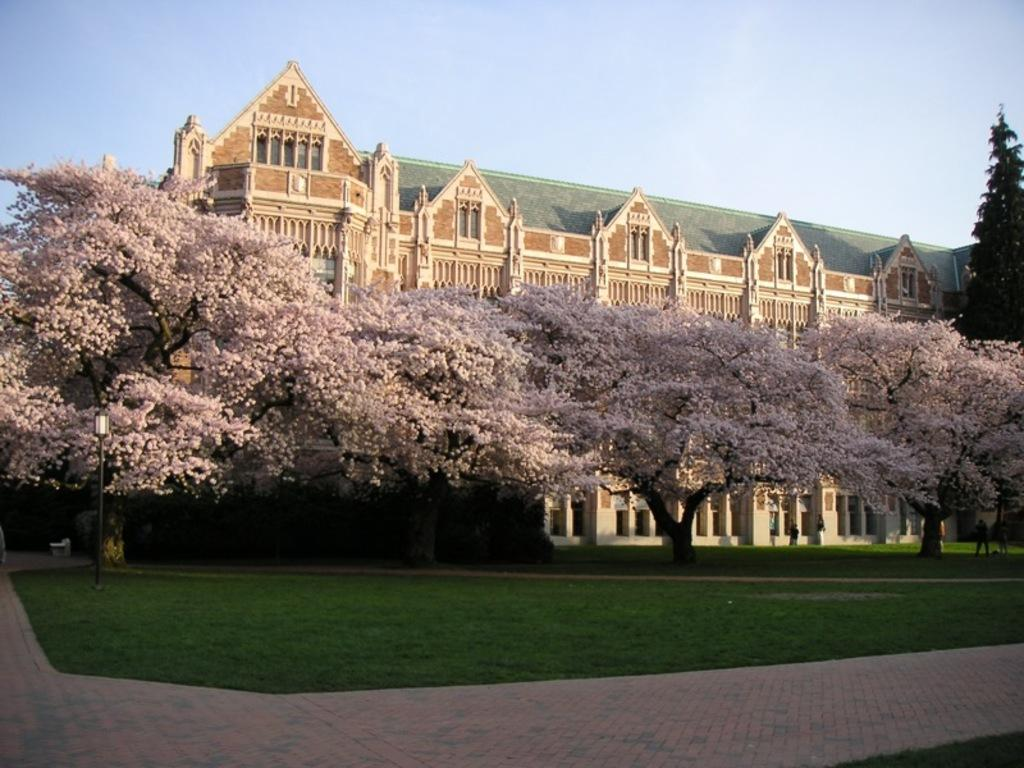What type of structure can be seen in the image? There is a building in the image. What natural elements are present in the image? There are trees and grass visible in the image. What type of lighting is present in the image? There is a pole light in the image. What is the condition of the sky in the image? The sky is blue and cloudy in the image. What type of growth can be seen on the building in the image? There is no visible growth on the building in the image. Can you describe the bath that is present in the image? There is no bath present in the image. 